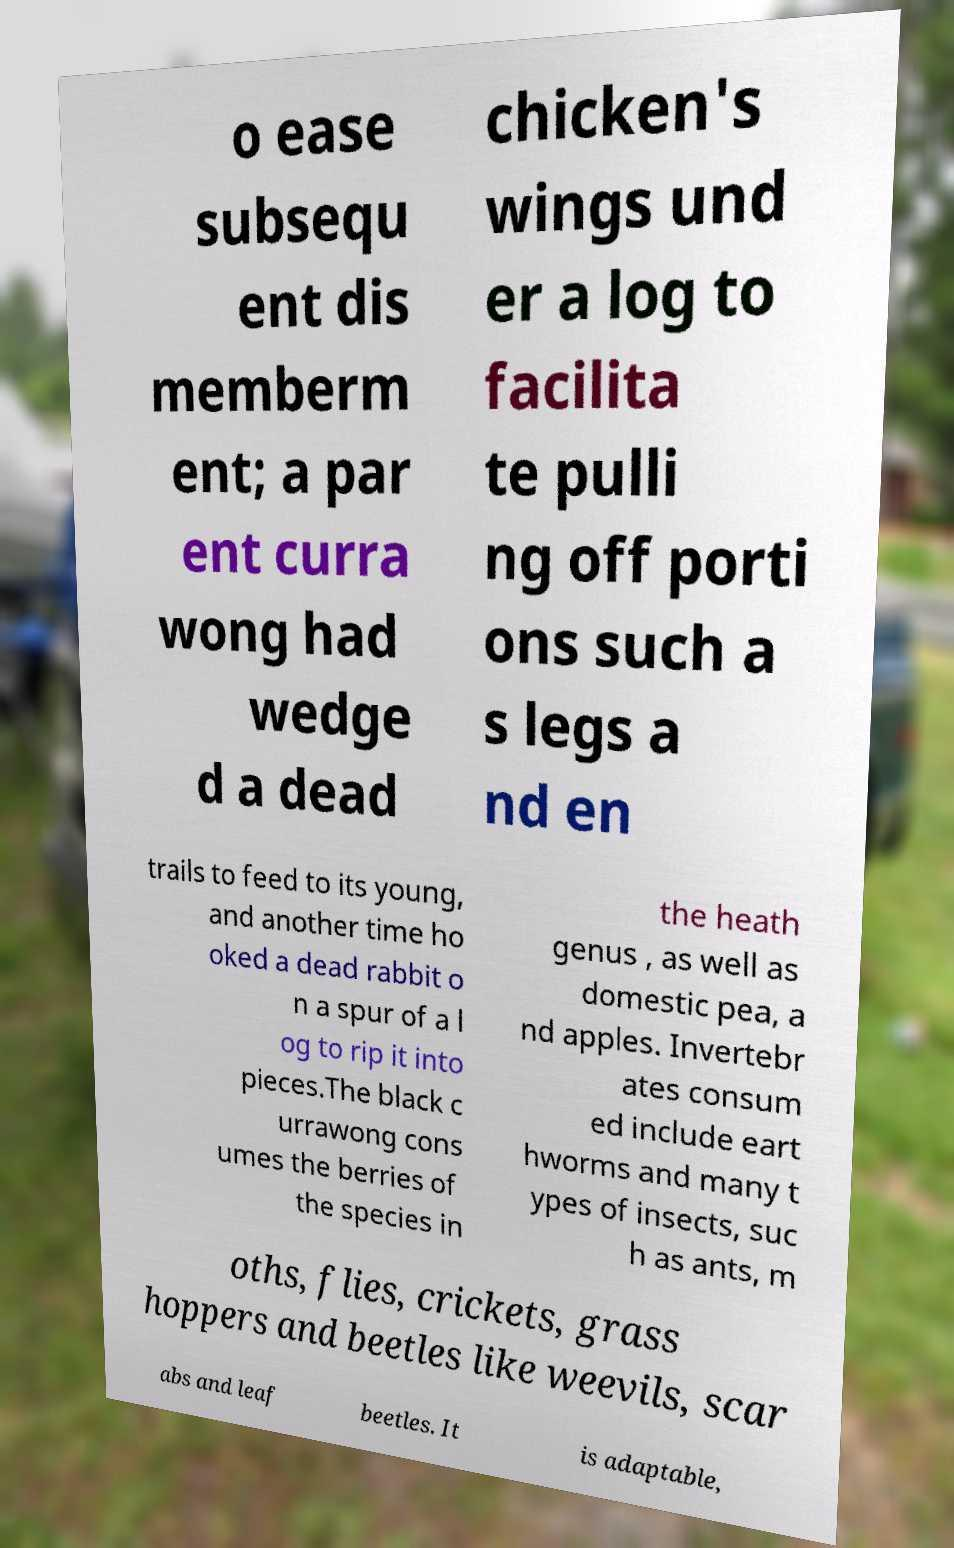For documentation purposes, I need the text within this image transcribed. Could you provide that? o ease subsequ ent dis memberm ent; a par ent curra wong had wedge d a dead chicken's wings und er a log to facilita te pulli ng off porti ons such a s legs a nd en trails to feed to its young, and another time ho oked a dead rabbit o n a spur of a l og to rip it into pieces.The black c urrawong cons umes the berries of the species in the heath genus , as well as domestic pea, a nd apples. Invertebr ates consum ed include eart hworms and many t ypes of insects, suc h as ants, m oths, flies, crickets, grass hoppers and beetles like weevils, scar abs and leaf beetles. It is adaptable, 